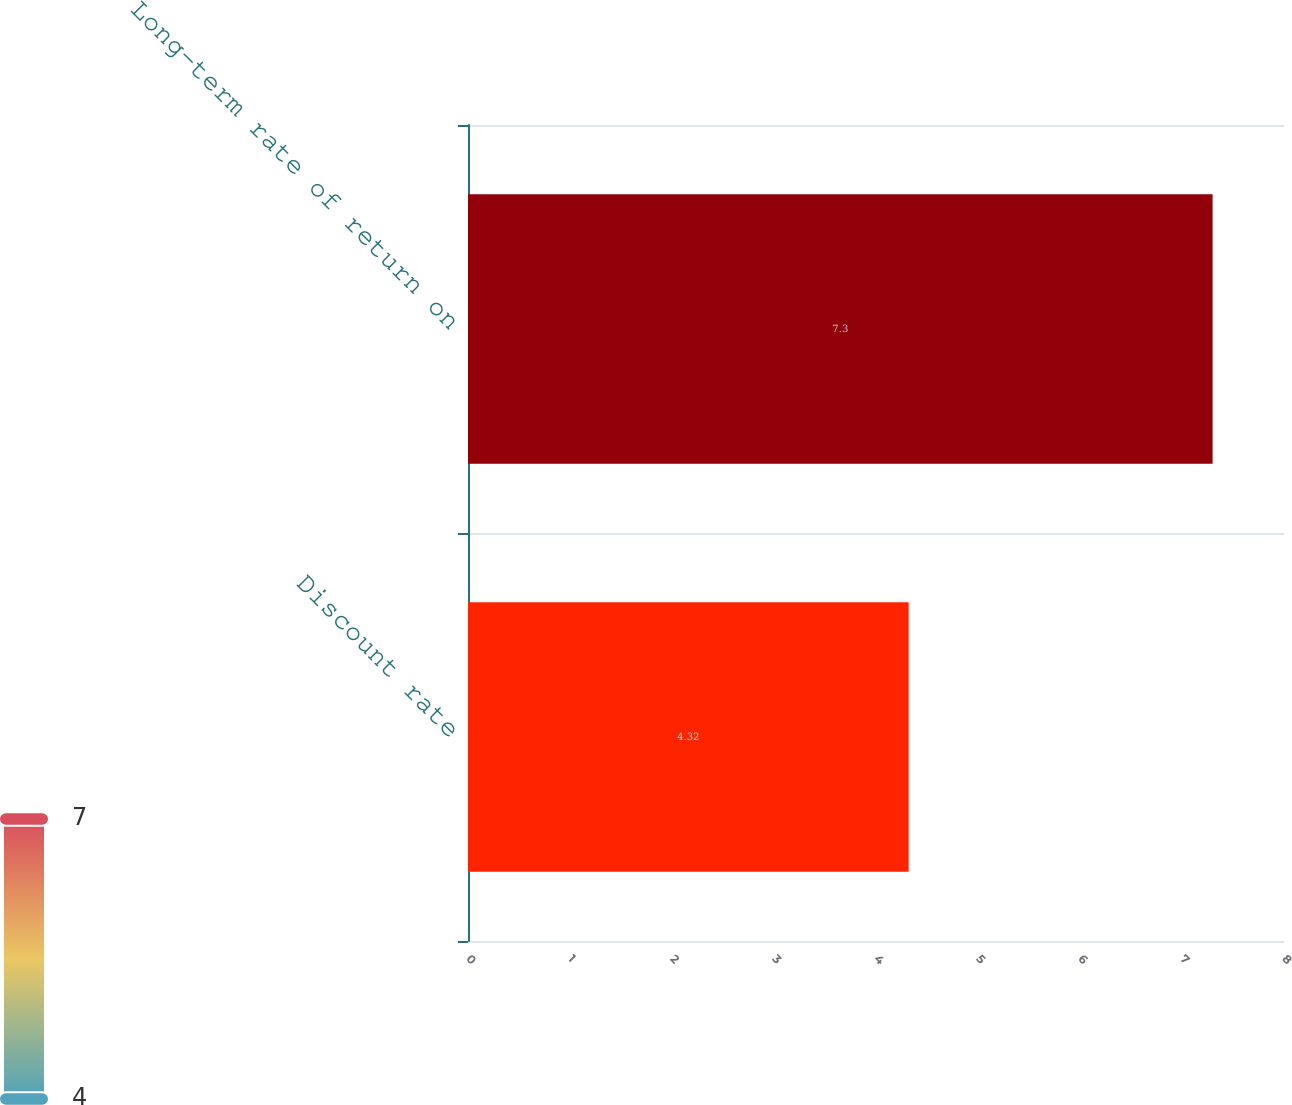Convert chart. <chart><loc_0><loc_0><loc_500><loc_500><bar_chart><fcel>Discount rate<fcel>Long-term rate of return on<nl><fcel>4.32<fcel>7.3<nl></chart> 